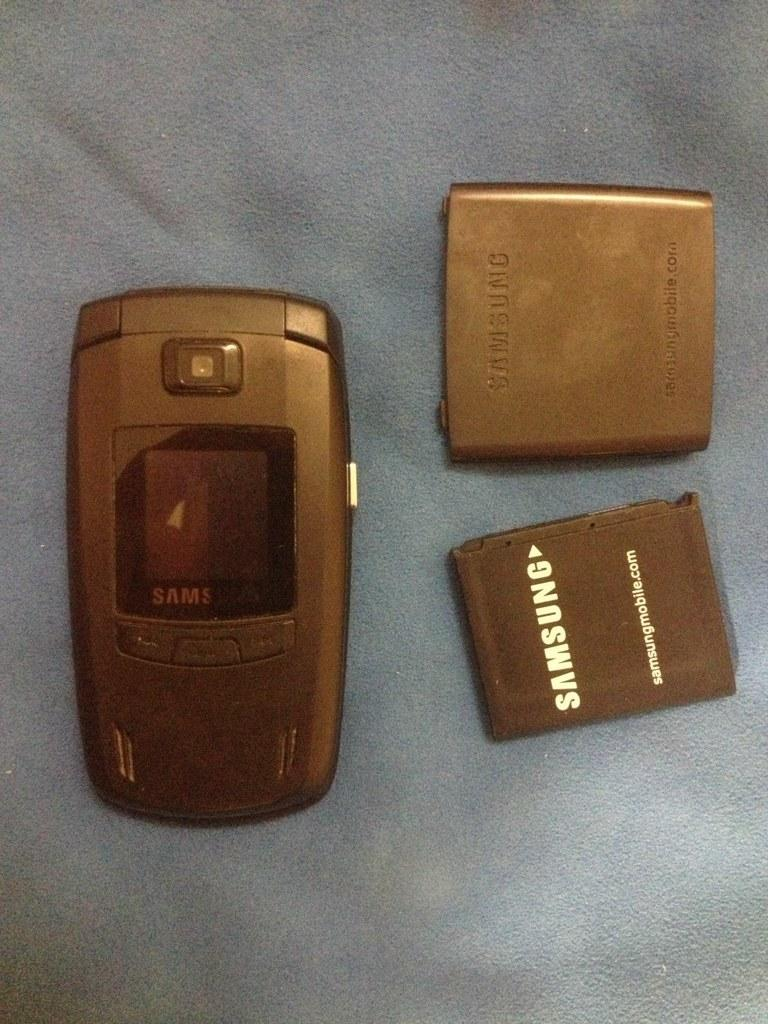<image>
Relay a brief, clear account of the picture shown. A Samsung phone and a couple of batteries. 